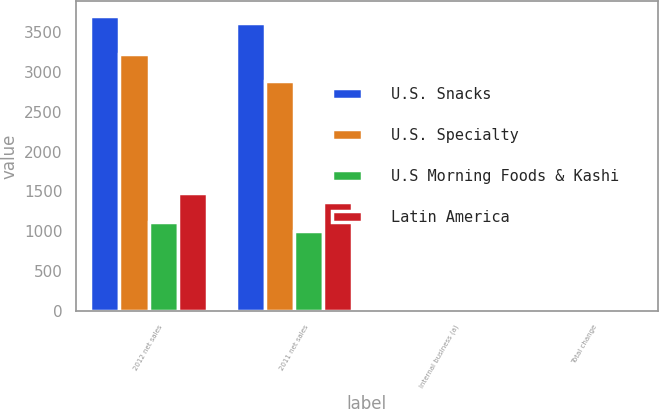Convert chart. <chart><loc_0><loc_0><loc_500><loc_500><stacked_bar_chart><ecel><fcel>2012 net sales<fcel>2011 net sales<fcel>Internal business (a)<fcel>Total change<nl><fcel>U.S. Snacks<fcel>3707<fcel>3611<fcel>2.7<fcel>2.7<nl><fcel>U.S. Specialty<fcel>3226<fcel>2883<fcel>1.9<fcel>11.9<nl><fcel>U.S Morning Foods & Kashi<fcel>1121<fcel>1008<fcel>7.4<fcel>11.2<nl><fcel>Latin America<fcel>1485<fcel>1371<fcel>7<fcel>8.3<nl></chart> 